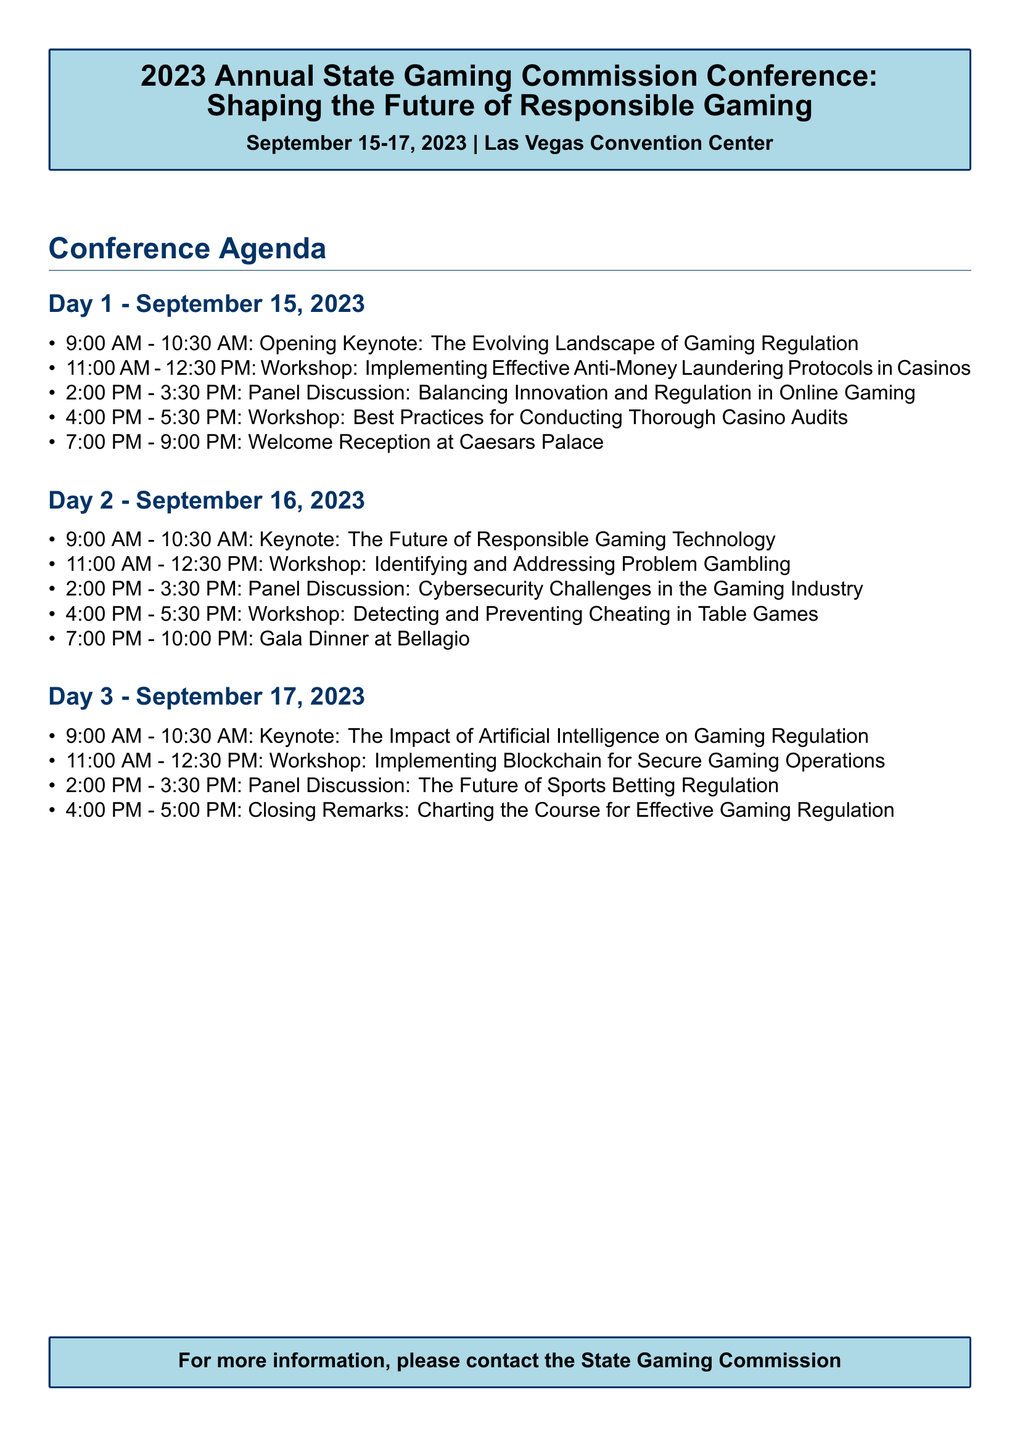What is the title of the conference? The title of the conference is stated at the beginning of the document.
Answer: 2023 Annual State Gaming Commission Conference: Shaping the Future of Responsible Gaming Who is the facilitator for the workshop on Anti-Money Laundering Protocols? The document lists the facilitator for each workshop, including this one.
Answer: Jennifer Shasky Calvery What time does the Gala Dinner start on Day 2? The schedule clearly indicates the start time for networking events on each day.
Answer: 7:00 PM How many panel discussions are scheduled across the three days? The total number of panel discussions can be counted from the agenda items listed.
Answer: 3 Who is the speaker for the keynote on Day 3? The document specifies the speaker for each keynote session, including Day 3.
Answer: Dr. Bo Bernhard What is the date range of the conference? The date range is provided at the top of the document.
Answer: September 15-17, 2023 What workshop is scheduled immediately after the Opening Keynote? The order of sessions shows this specific arrangement in the agenda.
Answer: Implementing Effective Anti-Money Laundering Protocols in Casinos What is the venue of the conference? The venue information is stated next to the date at the beginning of the document.
Answer: Las Vegas Convention Center 